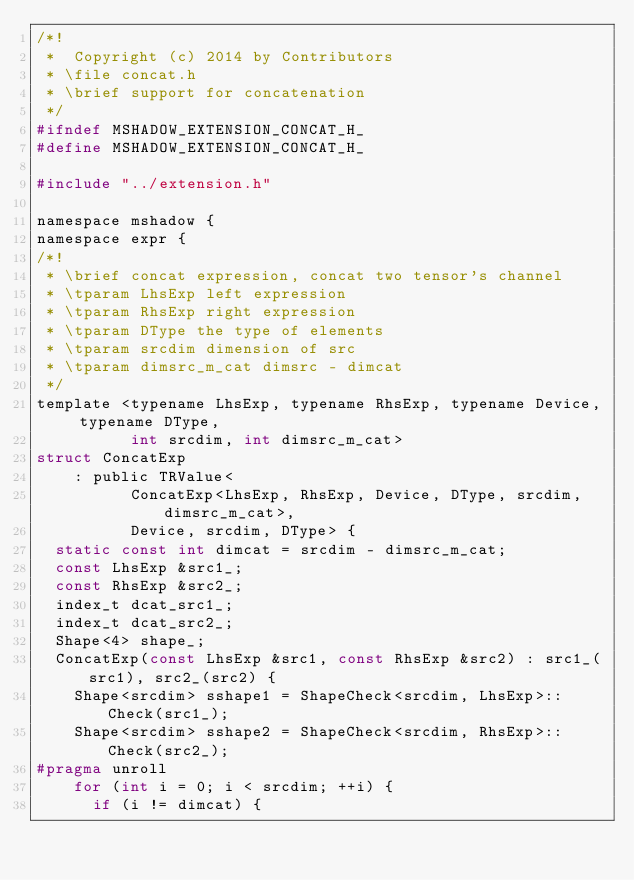<code> <loc_0><loc_0><loc_500><loc_500><_C_>/*!
 *  Copyright (c) 2014 by Contributors
 * \file concat.h
 * \brief support for concatenation
 */
#ifndef MSHADOW_EXTENSION_CONCAT_H_
#define MSHADOW_EXTENSION_CONCAT_H_

#include "../extension.h"

namespace mshadow {
namespace expr {
/*!
 * \brief concat expression, concat two tensor's channel
 * \tparam LhsExp left expression
 * \tparam RhsExp right expression
 * \tparam DType the type of elements
 * \tparam srcdim dimension of src
 * \tparam dimsrc_m_cat dimsrc - dimcat
 */
template <typename LhsExp, typename RhsExp, typename Device, typename DType,
          int srcdim, int dimsrc_m_cat>
struct ConcatExp
    : public TRValue<
          ConcatExp<LhsExp, RhsExp, Device, DType, srcdim, dimsrc_m_cat>,
          Device, srcdim, DType> {
  static const int dimcat = srcdim - dimsrc_m_cat;
  const LhsExp &src1_;
  const RhsExp &src2_;
  index_t dcat_src1_;
  index_t dcat_src2_;
  Shape<4> shape_;
  ConcatExp(const LhsExp &src1, const RhsExp &src2) : src1_(src1), src2_(src2) {
    Shape<srcdim> sshape1 = ShapeCheck<srcdim, LhsExp>::Check(src1_);
    Shape<srcdim> sshape2 = ShapeCheck<srcdim, RhsExp>::Check(src2_);
#pragma unroll
    for (int i = 0; i < srcdim; ++i) {
      if (i != dimcat) {</code> 